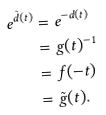<formula> <loc_0><loc_0><loc_500><loc_500>e ^ { \tilde { d } ( t ) } & = e ^ { - d ( t ) } \\ & = g ( t ) ^ { - 1 } \\ & = f ( - t ) \\ & = \tilde { g } ( t ) .</formula> 